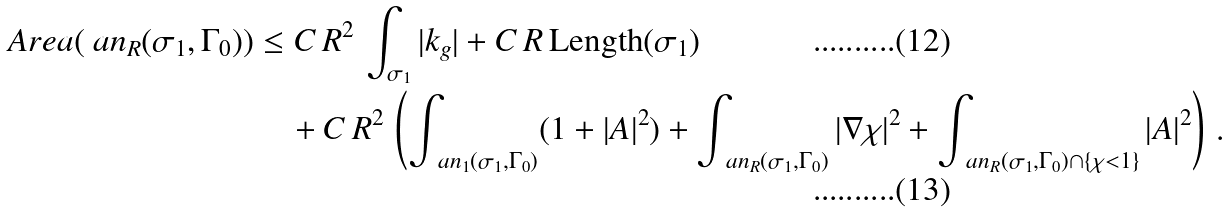<formula> <loc_0><loc_0><loc_500><loc_500>\ A r e a ( \ a n _ { R } ( \sigma _ { 1 } , \Gamma _ { 0 } ) ) & \leq C \, R ^ { 2 } \, \int _ { \sigma _ { 1 } } | k _ { g } | + C \, R \, { \text {Length} } ( \sigma _ { 1 } ) \\ & \quad + C \, R ^ { 2 } \, \left ( \int _ { \ a n _ { 1 } ( \sigma _ { 1 } , \Gamma _ { 0 } ) } ( 1 + | A | ^ { 2 } ) + \int _ { \ a n _ { R } ( \sigma _ { 1 } , \Gamma _ { 0 } ) } | \nabla \chi | ^ { 2 } + \int _ { \ a n _ { R } ( \sigma _ { 1 } , \Gamma _ { 0 } ) \cap \{ \chi < 1 \} } | A | ^ { 2 } \right ) \, .</formula> 